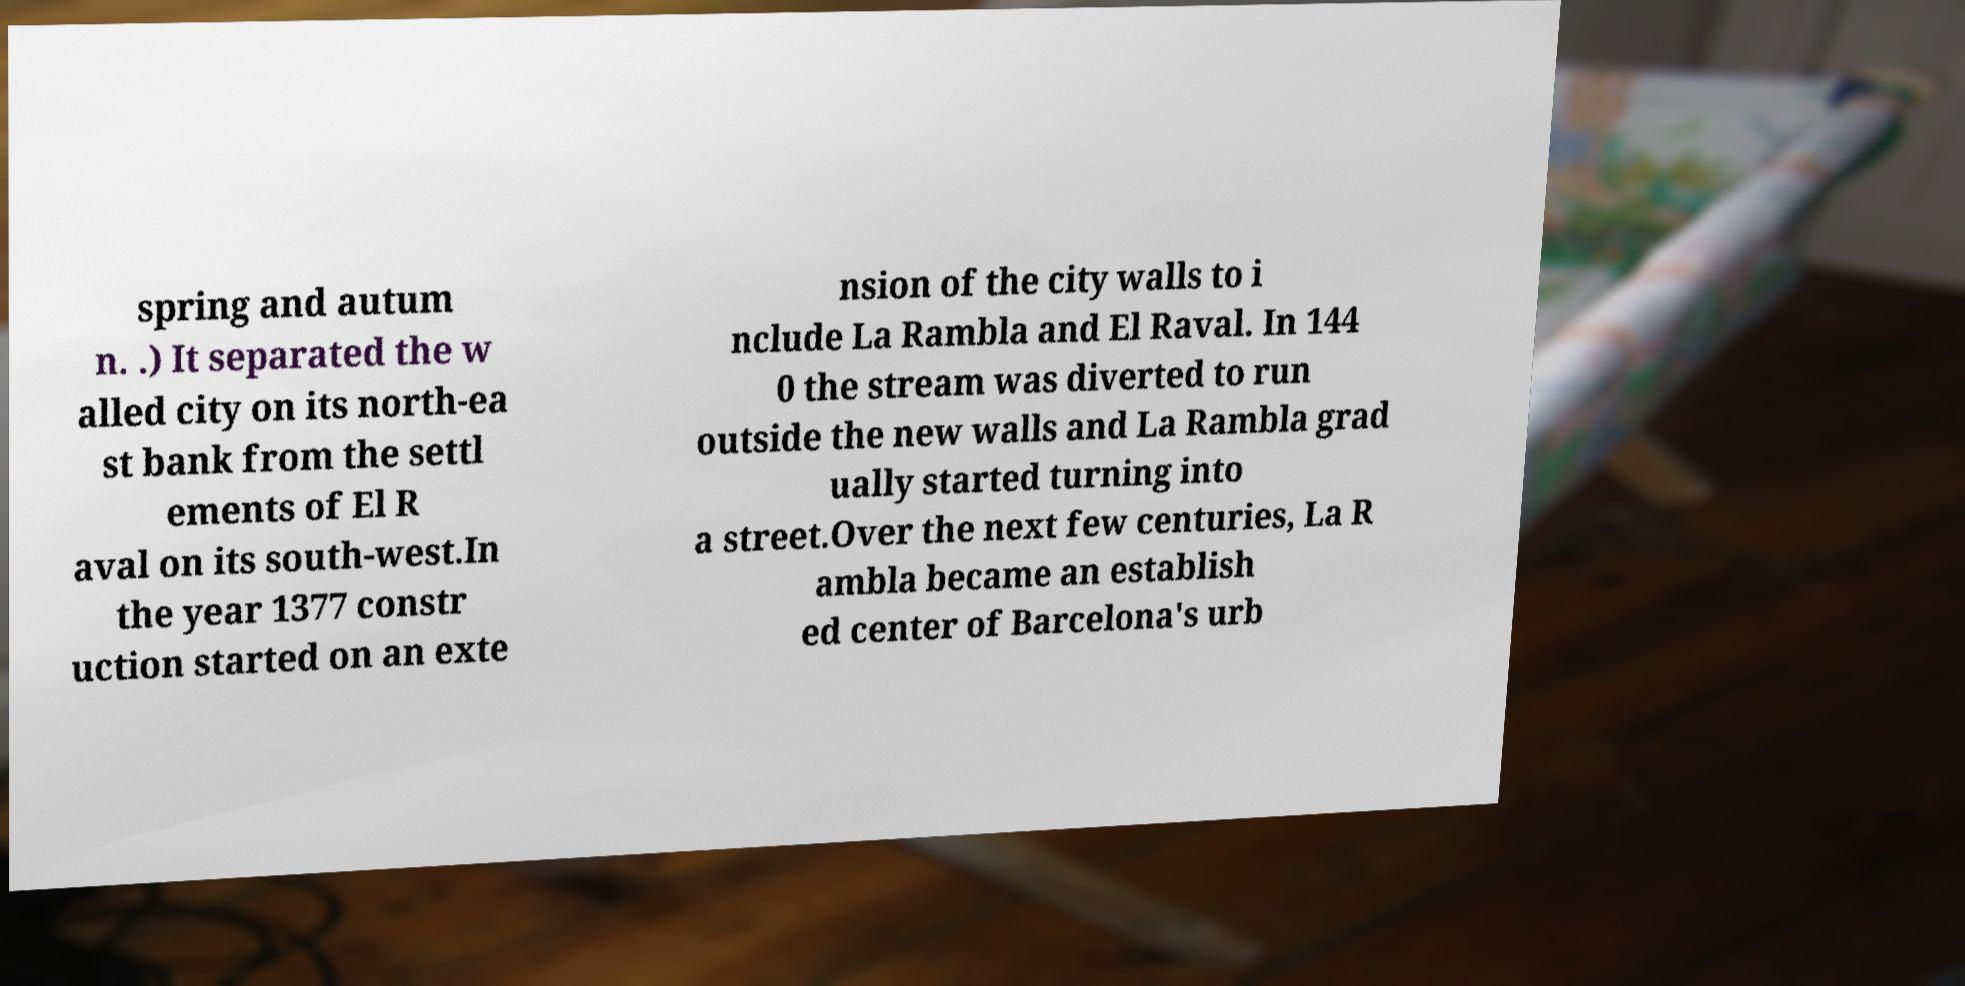Could you extract and type out the text from this image? spring and autum n. .) It separated the w alled city on its north-ea st bank from the settl ements of El R aval on its south-west.In the year 1377 constr uction started on an exte nsion of the city walls to i nclude La Rambla and El Raval. In 144 0 the stream was diverted to run outside the new walls and La Rambla grad ually started turning into a street.Over the next few centuries, La R ambla became an establish ed center of Barcelona's urb 